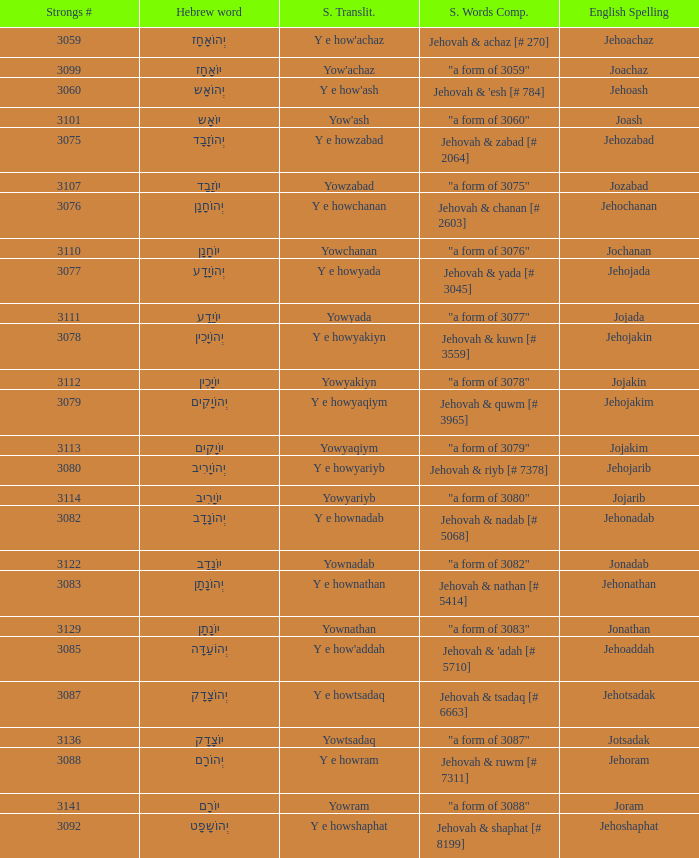Would you mind parsing the complete table? {'header': ['Strongs #', 'Hebrew word', 'S. Translit.', 'S. Words Comp.', 'English Spelling'], 'rows': [['3059', 'יְהוֹאָחָז', "Y e how'achaz", 'Jehovah & achaz [# 270]', 'Jehoachaz'], ['3099', 'יוֹאָחָז', "Yow'achaz", '"a form of 3059"', 'Joachaz'], ['3060', 'יְהוֹאָש', "Y e how'ash", "Jehovah & 'esh [# 784]", 'Jehoash'], ['3101', 'יוֹאָש', "Yow'ash", '"a form of 3060"', 'Joash'], ['3075', 'יְהוֹזָבָד', 'Y e howzabad', 'Jehovah & zabad [# 2064]', 'Jehozabad'], ['3107', 'יוֹזָבָד', 'Yowzabad', '"a form of 3075"', 'Jozabad'], ['3076', 'יְהוֹחָנָן', 'Y e howchanan', 'Jehovah & chanan [# 2603]', 'Jehochanan'], ['3110', 'יוֹחָנָן', 'Yowchanan', '"a form of 3076"', 'Jochanan'], ['3077', 'יְהוֹיָדָע', 'Y e howyada', 'Jehovah & yada [# 3045]', 'Jehojada'], ['3111', 'יוֹיָדָע', 'Yowyada', '"a form of 3077"', 'Jojada'], ['3078', 'יְהוֹיָכִין', 'Y e howyakiyn', 'Jehovah & kuwn [# 3559]', 'Jehojakin'], ['3112', 'יוֹיָכִין', 'Yowyakiyn', '"a form of 3078"', 'Jojakin'], ['3079', 'יְהוֹיָקִים', 'Y e howyaqiym', 'Jehovah & quwm [# 3965]', 'Jehojakim'], ['3113', 'יוֹיָקִים', 'Yowyaqiym', '"a form of 3079"', 'Jojakim'], ['3080', 'יְהוֹיָרִיב', 'Y e howyariyb', 'Jehovah & riyb [# 7378]', 'Jehojarib'], ['3114', 'יוֹיָרִיב', 'Yowyariyb', '"a form of 3080"', 'Jojarib'], ['3082', 'יְהוֹנָדָב', 'Y e hownadab', 'Jehovah & nadab [# 5068]', 'Jehonadab'], ['3122', 'יוֹנָדָב', 'Yownadab', '"a form of 3082"', 'Jonadab'], ['3083', 'יְהוֹנָתָן', 'Y e hownathan', 'Jehovah & nathan [# 5414]', 'Jehonathan'], ['3129', 'יוֹנָתָן', 'Yownathan', '"a form of 3083"', 'Jonathan'], ['3085', 'יְהוֹעַדָּה', "Y e how'addah", "Jehovah & 'adah [# 5710]", 'Jehoaddah'], ['3087', 'יְהוֹצָדָק', 'Y e howtsadaq', 'Jehovah & tsadaq [# 6663]', 'Jehotsadak'], ['3136', 'יוֹצָדָק', 'Yowtsadaq', '"a form of 3087"', 'Jotsadak'], ['3088', 'יְהוֹרָם', 'Y e howram', 'Jehovah & ruwm [# 7311]', 'Jehoram'], ['3141', 'יוֹרָם', 'Yowram', '"a form of 3088"', 'Joram'], ['3092', 'יְהוֹשָפָט', 'Y e howshaphat', 'Jehovah & shaphat [# 8199]', 'Jehoshaphat']]} What is the strong words compounded when the strongs transliteration is yowyariyb? "a form of 3080". 